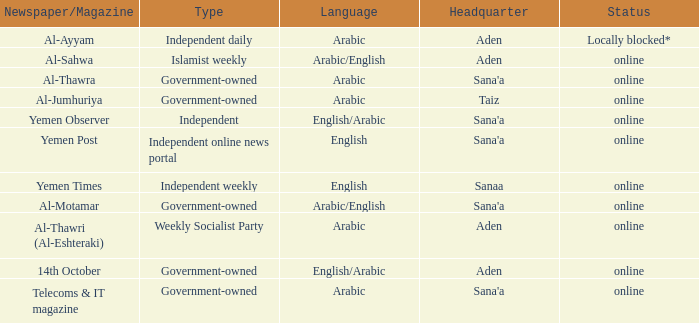What is the central location, when the language is english, and the category is an independent online news portal? Sana'a. 